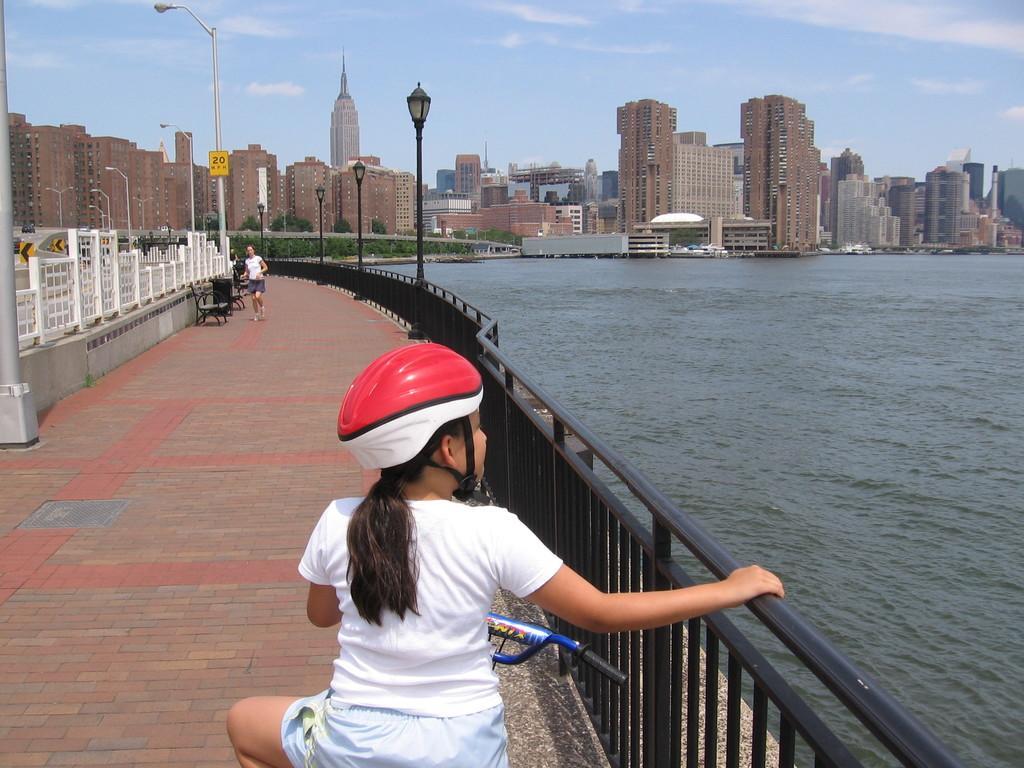Describe this image in one or two sentences. In this image there is a girl sitting on the cycle on the bridge. Beside her there is water. In the background there are tall buildings. On the bridge there are street lights. At the top there is sky. On the left side there is another woman who is running on the floor. 